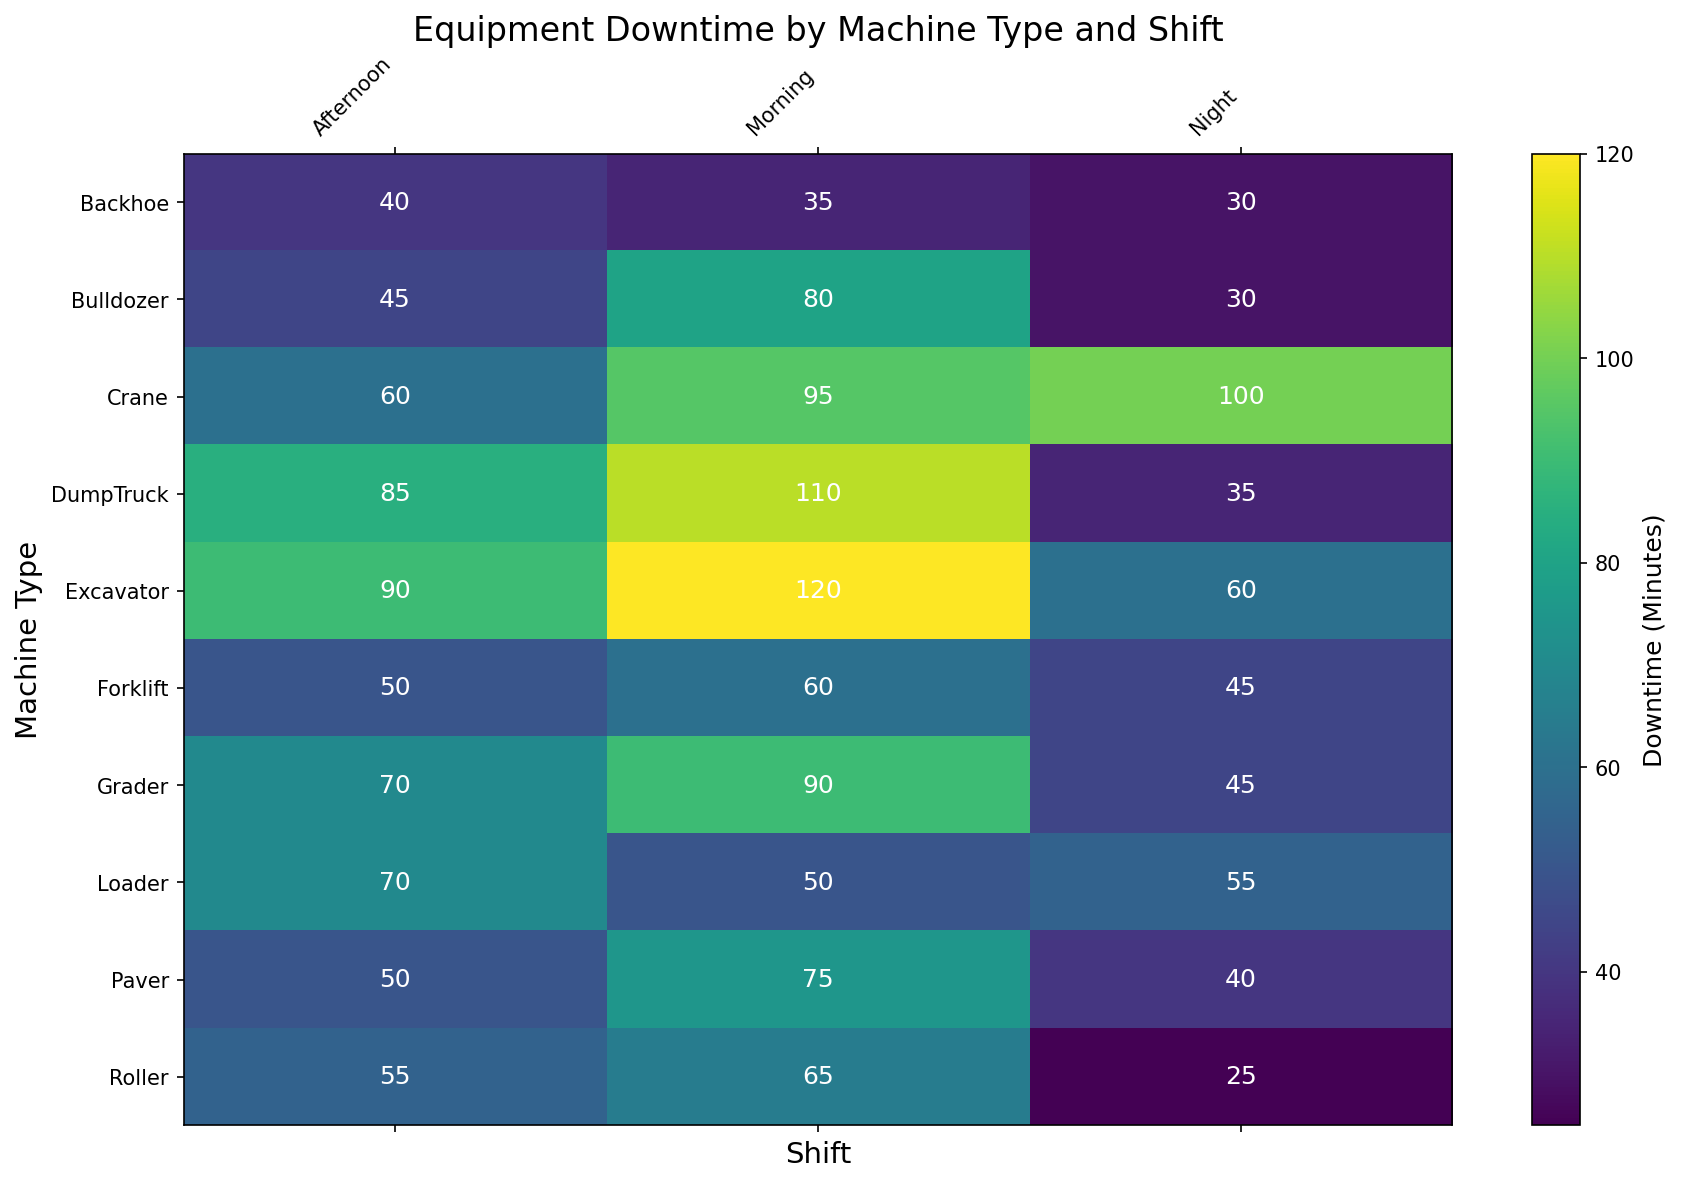Which machine type has the highest downtime in the morning shift? To determine this, look at the morning shift column and find the highest value. The Excavator has 120 minutes, which is the highest among all machine types.
Answer: Excavator How does the downtime of the Bulldozer in the afternoon compare to the Grader in the afternoon? Check the afternoon values for both Bulldozer and Grader. Bulldozer has 45 minutes and Grader has 70 minutes. 45 is less than 70.
Answer: Bulldozer has less downtime What is the total downtime for the Crane across all shifts? Sum the downtime values for the Crane in all shifts: 95 (Morning) + 60 (Afternoon) + 100 (Night) = 255 minutes.
Answer: 255 minutes Which shift generally shows the least downtime for most machines? By visually comparing the columns, the night shift appears to have the lowest downtime for most machines.
Answer: Night shift What is the average downtime for the Loader for all shifts? Add the downtime minutes across all shifts for the Loader and then divide by the number of shifts: (50 + 70 + 55) / 3 = 175 / 3 ≈ 58.33 minutes.
Answer: ~58.33 minutes Which machine type has the smallest range of downtime across different shifts? To find the range, subtract the smallest value for each machine from the largest value. Backhoe has 35 (Morning), 40 (Afternoon), and 30 (Night), giving a range of 40 - 30 = 10 minutes. This is the smallest range among all machines.
Answer: Backhoe Is there any machine type that has the same downtime for both the morning and afternoon shifts? Compare the morning and afternoon values for all machine types. There is no machine type with the same downtime for both shifts.
Answer: None Which shift has the highest total downtime summed across all machine types? To find this, sum the downtime values for all machine types in each shift: Morning = 120 + 80 + 95 + 50 + 110 + 75 + 65 + 90 + 35 + 60 = 820 minutes; Afternoon = 90 + 45 + 60 + 70 + 85 + 50 + 55 + 70 + 40 + 50 = 615 minutes; Night = 60 + 30 + 100 + 55 + 35 + 40 + 25 + 45 + 30 + 45 = 465 minutes. The morning shift has the highest downtime.
Answer: Morning shift 